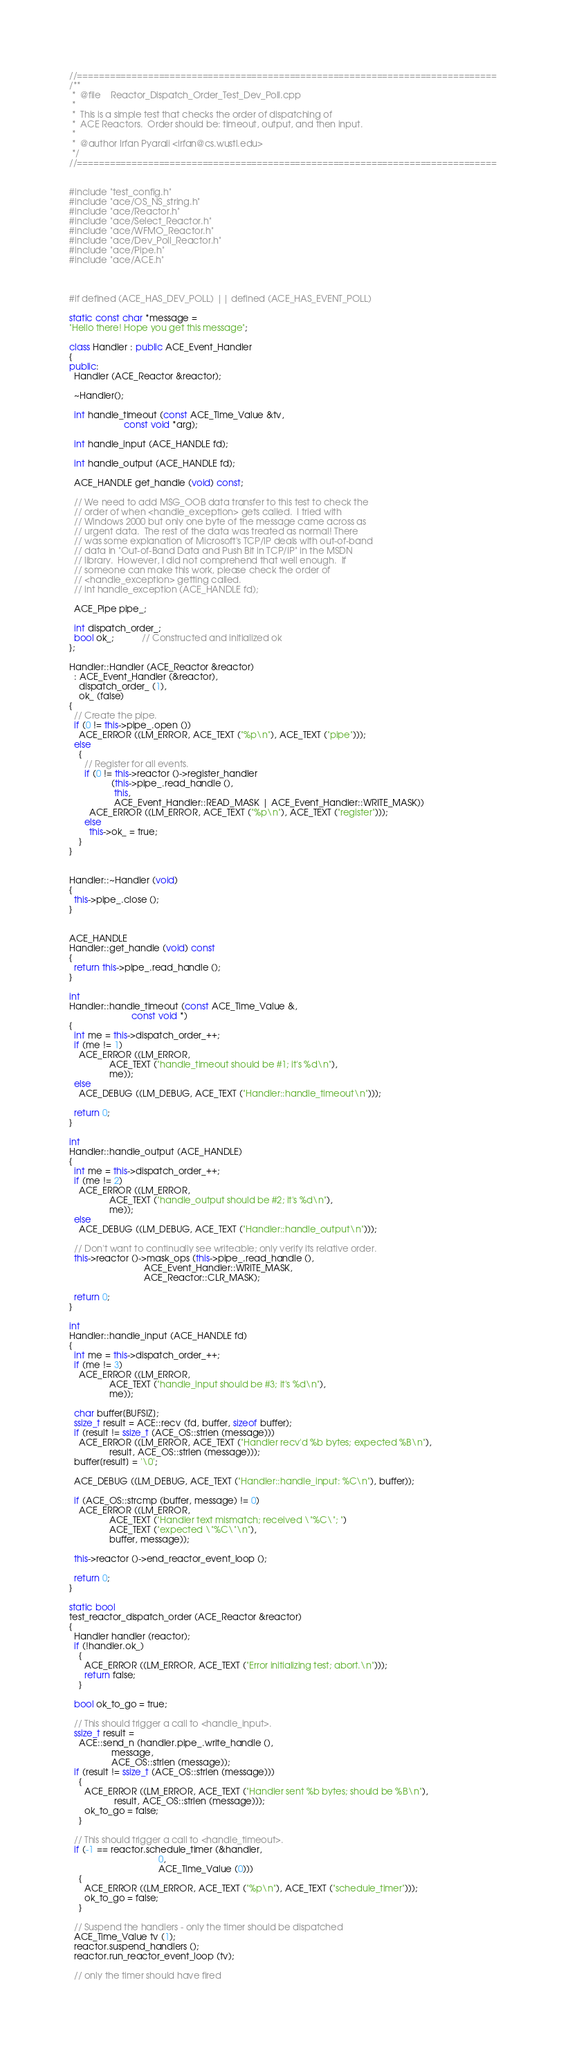<code> <loc_0><loc_0><loc_500><loc_500><_C++_>
//=============================================================================
/**
 *  @file    Reactor_Dispatch_Order_Test_Dev_Poll.cpp
 *
 *  This is a simple test that checks the order of dispatching of
 *  ACE Reactors.  Order should be: timeout, output, and then input.
 *
 *  @author Irfan Pyarali <irfan@cs.wustl.edu>
 */
//=============================================================================


#include "test_config.h"
#include "ace/OS_NS_string.h"
#include "ace/Reactor.h"
#include "ace/Select_Reactor.h"
#include "ace/WFMO_Reactor.h"
#include "ace/Dev_Poll_Reactor.h"
#include "ace/Pipe.h"
#include "ace/ACE.h"



#if defined (ACE_HAS_DEV_POLL) || defined (ACE_HAS_EVENT_POLL)

static const char *message =
"Hello there! Hope you get this message";

class Handler : public ACE_Event_Handler
{
public:
  Handler (ACE_Reactor &reactor);

  ~Handler();

  int handle_timeout (const ACE_Time_Value &tv,
                      const void *arg);

  int handle_input (ACE_HANDLE fd);

  int handle_output (ACE_HANDLE fd);

  ACE_HANDLE get_handle (void) const;

  // We need to add MSG_OOB data transfer to this test to check the
  // order of when <handle_exception> gets called.  I tried with
  // Windows 2000 but only one byte of the message came across as
  // urgent data.  The rest of the data was treated as normal! There
  // was some explanation of Microsoft's TCP/IP deals with out-of-band
  // data in "Out-of-Band Data and Push Bit in TCP/IP" in the MSDN
  // library.  However, I did not comprehend that well enough.  If
  // someone can make this work, please check the order of
  // <handle_exception> getting called.
  // int handle_exception (ACE_HANDLE fd);

  ACE_Pipe pipe_;

  int dispatch_order_;
  bool ok_;           // Constructed and initialized ok
};

Handler::Handler (ACE_Reactor &reactor)
  : ACE_Event_Handler (&reactor),
    dispatch_order_ (1),
    ok_ (false)
{
  // Create the pipe.
  if (0 != this->pipe_.open ())
    ACE_ERROR ((LM_ERROR, ACE_TEXT ("%p\n"), ACE_TEXT ("pipe")));
  else
    {
      // Register for all events.
      if (0 != this->reactor ()->register_handler
                 (this->pipe_.read_handle (),
                  this,
                  ACE_Event_Handler::READ_MASK | ACE_Event_Handler::WRITE_MASK))
        ACE_ERROR ((LM_ERROR, ACE_TEXT ("%p\n"), ACE_TEXT ("register")));
      else
        this->ok_ = true;
    }
}


Handler::~Handler (void)
{
  this->pipe_.close ();
}


ACE_HANDLE
Handler::get_handle (void) const
{
  return this->pipe_.read_handle ();
}

int
Handler::handle_timeout (const ACE_Time_Value &,
                         const void *)
{
  int me = this->dispatch_order_++;
  if (me != 1)
    ACE_ERROR ((LM_ERROR,
                ACE_TEXT ("handle_timeout should be #1; it's %d\n"),
                me));
  else
    ACE_DEBUG ((LM_DEBUG, ACE_TEXT ("Handler::handle_timeout\n")));

  return 0;
}

int
Handler::handle_output (ACE_HANDLE)
{
  int me = this->dispatch_order_++;
  if (me != 2)
    ACE_ERROR ((LM_ERROR,
                ACE_TEXT ("handle_output should be #2; it's %d\n"),
                me));
  else
    ACE_DEBUG ((LM_DEBUG, ACE_TEXT ("Handler::handle_output\n")));

  // Don't want to continually see writeable; only verify its relative order.
  this->reactor ()->mask_ops (this->pipe_.read_handle (),
                              ACE_Event_Handler::WRITE_MASK,
                              ACE_Reactor::CLR_MASK);

  return 0;
}

int
Handler::handle_input (ACE_HANDLE fd)
{
  int me = this->dispatch_order_++;
  if (me != 3)
    ACE_ERROR ((LM_ERROR,
                ACE_TEXT ("handle_input should be #3; it's %d\n"),
                me));

  char buffer[BUFSIZ];
  ssize_t result = ACE::recv (fd, buffer, sizeof buffer);
  if (result != ssize_t (ACE_OS::strlen (message)))
    ACE_ERROR ((LM_ERROR, ACE_TEXT ("Handler recv'd %b bytes; expected %B\n"),
                result, ACE_OS::strlen (message)));
  buffer[result] = '\0';

  ACE_DEBUG ((LM_DEBUG, ACE_TEXT ("Handler::handle_input: %C\n"), buffer));

  if (ACE_OS::strcmp (buffer, message) != 0)
    ACE_ERROR ((LM_ERROR,
                ACE_TEXT ("Handler text mismatch; received \"%C\"; ")
                ACE_TEXT ("expected \"%C\"\n"),
                buffer, message));

  this->reactor ()->end_reactor_event_loop ();

  return 0;
}

static bool
test_reactor_dispatch_order (ACE_Reactor &reactor)
{
  Handler handler (reactor);
  if (!handler.ok_)
    {
      ACE_ERROR ((LM_ERROR, ACE_TEXT ("Error initializing test; abort.\n")));
      return false;
    }

  bool ok_to_go = true;

  // This should trigger a call to <handle_input>.
  ssize_t result =
    ACE::send_n (handler.pipe_.write_handle (),
                 message,
                 ACE_OS::strlen (message));
  if (result != ssize_t (ACE_OS::strlen (message)))
    {
      ACE_ERROR ((LM_ERROR, ACE_TEXT ("Handler sent %b bytes; should be %B\n"),
                  result, ACE_OS::strlen (message)));
      ok_to_go = false;
    }

  // This should trigger a call to <handle_timeout>.
  if (-1 == reactor.schedule_timer (&handler,
                                    0,
                                    ACE_Time_Value (0)))
    {
      ACE_ERROR ((LM_ERROR, ACE_TEXT ("%p\n"), ACE_TEXT ("schedule_timer")));
      ok_to_go = false;
    }

  // Suspend the handlers - only the timer should be dispatched
  ACE_Time_Value tv (1);
  reactor.suspend_handlers ();
  reactor.run_reactor_event_loop (tv);

  // only the timer should have fired</code> 